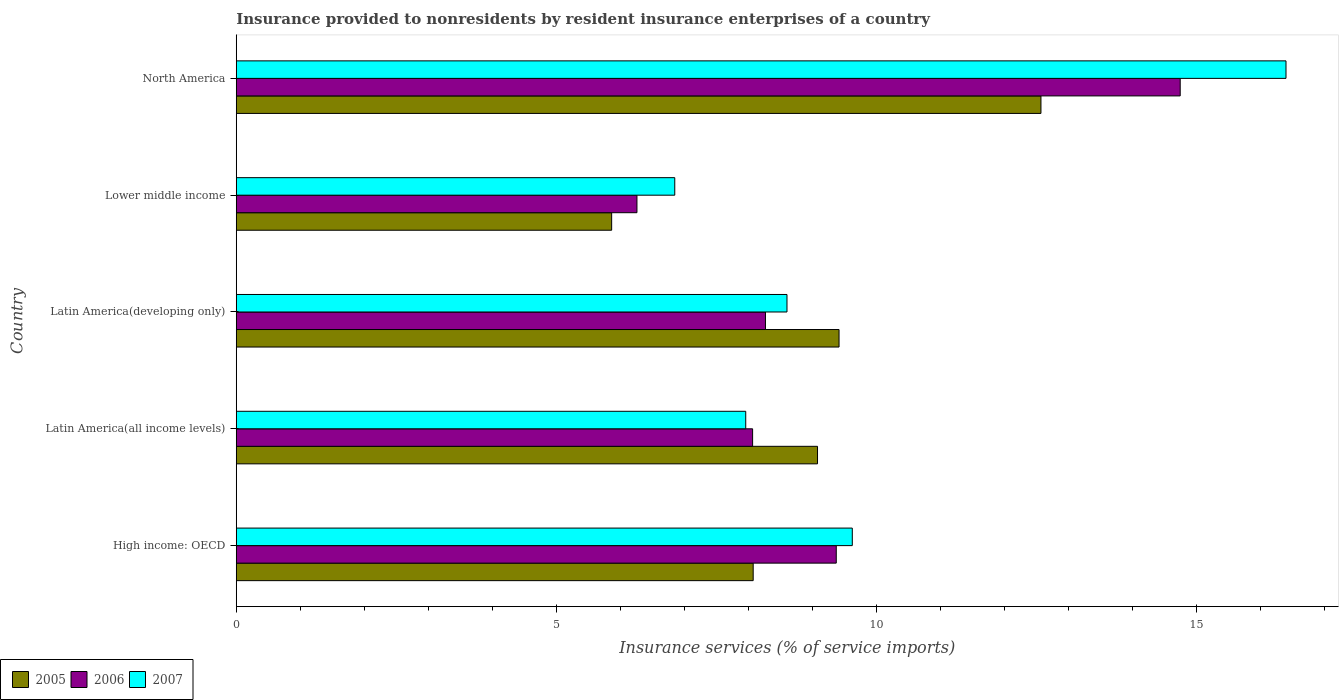How many groups of bars are there?
Ensure brevity in your answer.  5. Are the number of bars on each tick of the Y-axis equal?
Give a very brief answer. Yes. What is the label of the 2nd group of bars from the top?
Ensure brevity in your answer.  Lower middle income. What is the insurance provided to nonresidents in 2006 in North America?
Make the answer very short. 14.74. Across all countries, what is the maximum insurance provided to nonresidents in 2005?
Give a very brief answer. 12.57. Across all countries, what is the minimum insurance provided to nonresidents in 2006?
Your answer should be compact. 6.26. In which country was the insurance provided to nonresidents in 2007 maximum?
Offer a terse response. North America. In which country was the insurance provided to nonresidents in 2006 minimum?
Provide a short and direct response. Lower middle income. What is the total insurance provided to nonresidents in 2007 in the graph?
Give a very brief answer. 49.43. What is the difference between the insurance provided to nonresidents in 2005 in Latin America(developing only) and that in North America?
Make the answer very short. -3.15. What is the difference between the insurance provided to nonresidents in 2006 in High income: OECD and the insurance provided to nonresidents in 2007 in North America?
Give a very brief answer. -7.02. What is the average insurance provided to nonresidents in 2005 per country?
Make the answer very short. 9. What is the difference between the insurance provided to nonresidents in 2007 and insurance provided to nonresidents in 2006 in Lower middle income?
Keep it short and to the point. 0.59. What is the ratio of the insurance provided to nonresidents in 2005 in Latin America(all income levels) to that in North America?
Keep it short and to the point. 0.72. Is the difference between the insurance provided to nonresidents in 2007 in High income: OECD and Lower middle income greater than the difference between the insurance provided to nonresidents in 2006 in High income: OECD and Lower middle income?
Provide a succinct answer. No. What is the difference between the highest and the second highest insurance provided to nonresidents in 2006?
Offer a very short reply. 5.37. What is the difference between the highest and the lowest insurance provided to nonresidents in 2006?
Keep it short and to the point. 8.48. In how many countries, is the insurance provided to nonresidents in 2007 greater than the average insurance provided to nonresidents in 2007 taken over all countries?
Ensure brevity in your answer.  1. Is it the case that in every country, the sum of the insurance provided to nonresidents in 2006 and insurance provided to nonresidents in 2007 is greater than the insurance provided to nonresidents in 2005?
Provide a succinct answer. Yes. Are all the bars in the graph horizontal?
Provide a short and direct response. Yes. What is the difference between two consecutive major ticks on the X-axis?
Make the answer very short. 5. Are the values on the major ticks of X-axis written in scientific E-notation?
Provide a succinct answer. No. Does the graph contain any zero values?
Ensure brevity in your answer.  No. Does the graph contain grids?
Offer a very short reply. No. How many legend labels are there?
Offer a terse response. 3. How are the legend labels stacked?
Your response must be concise. Horizontal. What is the title of the graph?
Provide a succinct answer. Insurance provided to nonresidents by resident insurance enterprises of a country. Does "1999" appear as one of the legend labels in the graph?
Your response must be concise. No. What is the label or title of the X-axis?
Offer a terse response. Insurance services (% of service imports). What is the label or title of the Y-axis?
Ensure brevity in your answer.  Country. What is the Insurance services (% of service imports) of 2005 in High income: OECD?
Offer a terse response. 8.07. What is the Insurance services (% of service imports) in 2006 in High income: OECD?
Your answer should be very brief. 9.37. What is the Insurance services (% of service imports) of 2007 in High income: OECD?
Give a very brief answer. 9.62. What is the Insurance services (% of service imports) of 2005 in Latin America(all income levels)?
Keep it short and to the point. 9.08. What is the Insurance services (% of service imports) of 2006 in Latin America(all income levels)?
Keep it short and to the point. 8.06. What is the Insurance services (% of service imports) in 2007 in Latin America(all income levels)?
Offer a very short reply. 7.96. What is the Insurance services (% of service imports) in 2005 in Latin America(developing only)?
Offer a terse response. 9.41. What is the Insurance services (% of service imports) of 2006 in Latin America(developing only)?
Your answer should be compact. 8.27. What is the Insurance services (% of service imports) of 2007 in Latin America(developing only)?
Provide a succinct answer. 8.6. What is the Insurance services (% of service imports) in 2005 in Lower middle income?
Provide a succinct answer. 5.86. What is the Insurance services (% of service imports) in 2006 in Lower middle income?
Give a very brief answer. 6.26. What is the Insurance services (% of service imports) of 2007 in Lower middle income?
Make the answer very short. 6.85. What is the Insurance services (% of service imports) of 2005 in North America?
Your answer should be very brief. 12.57. What is the Insurance services (% of service imports) of 2006 in North America?
Ensure brevity in your answer.  14.74. What is the Insurance services (% of service imports) in 2007 in North America?
Your answer should be compact. 16.4. Across all countries, what is the maximum Insurance services (% of service imports) in 2005?
Keep it short and to the point. 12.57. Across all countries, what is the maximum Insurance services (% of service imports) in 2006?
Make the answer very short. 14.74. Across all countries, what is the maximum Insurance services (% of service imports) in 2007?
Provide a short and direct response. 16.4. Across all countries, what is the minimum Insurance services (% of service imports) in 2005?
Keep it short and to the point. 5.86. Across all countries, what is the minimum Insurance services (% of service imports) in 2006?
Offer a terse response. 6.26. Across all countries, what is the minimum Insurance services (% of service imports) in 2007?
Keep it short and to the point. 6.85. What is the total Insurance services (% of service imports) in 2005 in the graph?
Offer a terse response. 45. What is the total Insurance services (% of service imports) of 2006 in the graph?
Offer a terse response. 46.7. What is the total Insurance services (% of service imports) in 2007 in the graph?
Your answer should be very brief. 49.43. What is the difference between the Insurance services (% of service imports) of 2005 in High income: OECD and that in Latin America(all income levels)?
Ensure brevity in your answer.  -1. What is the difference between the Insurance services (% of service imports) of 2006 in High income: OECD and that in Latin America(all income levels)?
Your answer should be compact. 1.31. What is the difference between the Insurance services (% of service imports) in 2007 in High income: OECD and that in Latin America(all income levels)?
Offer a terse response. 1.66. What is the difference between the Insurance services (% of service imports) of 2005 in High income: OECD and that in Latin America(developing only)?
Offer a terse response. -1.34. What is the difference between the Insurance services (% of service imports) in 2006 in High income: OECD and that in Latin America(developing only)?
Offer a terse response. 1.11. What is the difference between the Insurance services (% of service imports) in 2007 in High income: OECD and that in Latin America(developing only)?
Your answer should be compact. 1.02. What is the difference between the Insurance services (% of service imports) in 2005 in High income: OECD and that in Lower middle income?
Ensure brevity in your answer.  2.21. What is the difference between the Insurance services (% of service imports) of 2006 in High income: OECD and that in Lower middle income?
Offer a terse response. 3.11. What is the difference between the Insurance services (% of service imports) in 2007 in High income: OECD and that in Lower middle income?
Offer a terse response. 2.77. What is the difference between the Insurance services (% of service imports) of 2005 in High income: OECD and that in North America?
Your answer should be compact. -4.49. What is the difference between the Insurance services (% of service imports) of 2006 in High income: OECD and that in North America?
Your answer should be very brief. -5.37. What is the difference between the Insurance services (% of service imports) in 2007 in High income: OECD and that in North America?
Give a very brief answer. -6.77. What is the difference between the Insurance services (% of service imports) in 2005 in Latin America(all income levels) and that in Latin America(developing only)?
Your response must be concise. -0.34. What is the difference between the Insurance services (% of service imports) of 2006 in Latin America(all income levels) and that in Latin America(developing only)?
Give a very brief answer. -0.2. What is the difference between the Insurance services (% of service imports) of 2007 in Latin America(all income levels) and that in Latin America(developing only)?
Make the answer very short. -0.64. What is the difference between the Insurance services (% of service imports) in 2005 in Latin America(all income levels) and that in Lower middle income?
Ensure brevity in your answer.  3.22. What is the difference between the Insurance services (% of service imports) of 2006 in Latin America(all income levels) and that in Lower middle income?
Your response must be concise. 1.81. What is the difference between the Insurance services (% of service imports) in 2007 in Latin America(all income levels) and that in Lower middle income?
Make the answer very short. 1.11. What is the difference between the Insurance services (% of service imports) of 2005 in Latin America(all income levels) and that in North America?
Ensure brevity in your answer.  -3.49. What is the difference between the Insurance services (% of service imports) in 2006 in Latin America(all income levels) and that in North America?
Provide a short and direct response. -6.68. What is the difference between the Insurance services (% of service imports) of 2007 in Latin America(all income levels) and that in North America?
Provide a short and direct response. -8.44. What is the difference between the Insurance services (% of service imports) in 2005 in Latin America(developing only) and that in Lower middle income?
Your response must be concise. 3.55. What is the difference between the Insurance services (% of service imports) in 2006 in Latin America(developing only) and that in Lower middle income?
Your answer should be very brief. 2.01. What is the difference between the Insurance services (% of service imports) in 2007 in Latin America(developing only) and that in Lower middle income?
Provide a succinct answer. 1.75. What is the difference between the Insurance services (% of service imports) in 2005 in Latin America(developing only) and that in North America?
Offer a very short reply. -3.15. What is the difference between the Insurance services (% of service imports) of 2006 in Latin America(developing only) and that in North America?
Keep it short and to the point. -6.48. What is the difference between the Insurance services (% of service imports) in 2007 in Latin America(developing only) and that in North America?
Provide a short and direct response. -7.79. What is the difference between the Insurance services (% of service imports) in 2005 in Lower middle income and that in North America?
Make the answer very short. -6.71. What is the difference between the Insurance services (% of service imports) of 2006 in Lower middle income and that in North America?
Your answer should be very brief. -8.48. What is the difference between the Insurance services (% of service imports) in 2007 in Lower middle income and that in North America?
Your answer should be very brief. -9.55. What is the difference between the Insurance services (% of service imports) of 2005 in High income: OECD and the Insurance services (% of service imports) of 2006 in Latin America(all income levels)?
Your answer should be very brief. 0.01. What is the difference between the Insurance services (% of service imports) of 2005 in High income: OECD and the Insurance services (% of service imports) of 2007 in Latin America(all income levels)?
Keep it short and to the point. 0.12. What is the difference between the Insurance services (% of service imports) in 2006 in High income: OECD and the Insurance services (% of service imports) in 2007 in Latin America(all income levels)?
Keep it short and to the point. 1.41. What is the difference between the Insurance services (% of service imports) in 2005 in High income: OECD and the Insurance services (% of service imports) in 2006 in Latin America(developing only)?
Keep it short and to the point. -0.19. What is the difference between the Insurance services (% of service imports) in 2005 in High income: OECD and the Insurance services (% of service imports) in 2007 in Latin America(developing only)?
Keep it short and to the point. -0.53. What is the difference between the Insurance services (% of service imports) of 2006 in High income: OECD and the Insurance services (% of service imports) of 2007 in Latin America(developing only)?
Provide a succinct answer. 0.77. What is the difference between the Insurance services (% of service imports) in 2005 in High income: OECD and the Insurance services (% of service imports) in 2006 in Lower middle income?
Your answer should be very brief. 1.82. What is the difference between the Insurance services (% of service imports) of 2005 in High income: OECD and the Insurance services (% of service imports) of 2007 in Lower middle income?
Provide a succinct answer. 1.22. What is the difference between the Insurance services (% of service imports) of 2006 in High income: OECD and the Insurance services (% of service imports) of 2007 in Lower middle income?
Provide a succinct answer. 2.52. What is the difference between the Insurance services (% of service imports) in 2005 in High income: OECD and the Insurance services (% of service imports) in 2006 in North America?
Your answer should be compact. -6.67. What is the difference between the Insurance services (% of service imports) of 2005 in High income: OECD and the Insurance services (% of service imports) of 2007 in North America?
Give a very brief answer. -8.32. What is the difference between the Insurance services (% of service imports) in 2006 in High income: OECD and the Insurance services (% of service imports) in 2007 in North America?
Your answer should be compact. -7.02. What is the difference between the Insurance services (% of service imports) of 2005 in Latin America(all income levels) and the Insurance services (% of service imports) of 2006 in Latin America(developing only)?
Give a very brief answer. 0.81. What is the difference between the Insurance services (% of service imports) of 2005 in Latin America(all income levels) and the Insurance services (% of service imports) of 2007 in Latin America(developing only)?
Make the answer very short. 0.48. What is the difference between the Insurance services (% of service imports) of 2006 in Latin America(all income levels) and the Insurance services (% of service imports) of 2007 in Latin America(developing only)?
Make the answer very short. -0.54. What is the difference between the Insurance services (% of service imports) of 2005 in Latin America(all income levels) and the Insurance services (% of service imports) of 2006 in Lower middle income?
Provide a short and direct response. 2.82. What is the difference between the Insurance services (% of service imports) of 2005 in Latin America(all income levels) and the Insurance services (% of service imports) of 2007 in Lower middle income?
Your response must be concise. 2.23. What is the difference between the Insurance services (% of service imports) of 2006 in Latin America(all income levels) and the Insurance services (% of service imports) of 2007 in Lower middle income?
Your response must be concise. 1.22. What is the difference between the Insurance services (% of service imports) of 2005 in Latin America(all income levels) and the Insurance services (% of service imports) of 2006 in North America?
Keep it short and to the point. -5.66. What is the difference between the Insurance services (% of service imports) in 2005 in Latin America(all income levels) and the Insurance services (% of service imports) in 2007 in North America?
Your answer should be very brief. -7.32. What is the difference between the Insurance services (% of service imports) of 2006 in Latin America(all income levels) and the Insurance services (% of service imports) of 2007 in North America?
Give a very brief answer. -8.33. What is the difference between the Insurance services (% of service imports) in 2005 in Latin America(developing only) and the Insurance services (% of service imports) in 2006 in Lower middle income?
Provide a short and direct response. 3.16. What is the difference between the Insurance services (% of service imports) of 2005 in Latin America(developing only) and the Insurance services (% of service imports) of 2007 in Lower middle income?
Give a very brief answer. 2.57. What is the difference between the Insurance services (% of service imports) in 2006 in Latin America(developing only) and the Insurance services (% of service imports) in 2007 in Lower middle income?
Provide a short and direct response. 1.42. What is the difference between the Insurance services (% of service imports) in 2005 in Latin America(developing only) and the Insurance services (% of service imports) in 2006 in North America?
Offer a terse response. -5.33. What is the difference between the Insurance services (% of service imports) of 2005 in Latin America(developing only) and the Insurance services (% of service imports) of 2007 in North America?
Provide a succinct answer. -6.98. What is the difference between the Insurance services (% of service imports) in 2006 in Latin America(developing only) and the Insurance services (% of service imports) in 2007 in North America?
Your answer should be compact. -8.13. What is the difference between the Insurance services (% of service imports) in 2005 in Lower middle income and the Insurance services (% of service imports) in 2006 in North America?
Provide a succinct answer. -8.88. What is the difference between the Insurance services (% of service imports) in 2005 in Lower middle income and the Insurance services (% of service imports) in 2007 in North America?
Your response must be concise. -10.53. What is the difference between the Insurance services (% of service imports) of 2006 in Lower middle income and the Insurance services (% of service imports) of 2007 in North America?
Provide a short and direct response. -10.14. What is the average Insurance services (% of service imports) of 2005 per country?
Ensure brevity in your answer.  9. What is the average Insurance services (% of service imports) of 2006 per country?
Your response must be concise. 9.34. What is the average Insurance services (% of service imports) in 2007 per country?
Provide a succinct answer. 9.89. What is the difference between the Insurance services (% of service imports) in 2005 and Insurance services (% of service imports) in 2006 in High income: OECD?
Ensure brevity in your answer.  -1.3. What is the difference between the Insurance services (% of service imports) of 2005 and Insurance services (% of service imports) of 2007 in High income: OECD?
Provide a succinct answer. -1.55. What is the difference between the Insurance services (% of service imports) of 2006 and Insurance services (% of service imports) of 2007 in High income: OECD?
Ensure brevity in your answer.  -0.25. What is the difference between the Insurance services (% of service imports) in 2005 and Insurance services (% of service imports) in 2006 in Latin America(all income levels)?
Make the answer very short. 1.01. What is the difference between the Insurance services (% of service imports) in 2005 and Insurance services (% of service imports) in 2007 in Latin America(all income levels)?
Ensure brevity in your answer.  1.12. What is the difference between the Insurance services (% of service imports) of 2006 and Insurance services (% of service imports) of 2007 in Latin America(all income levels)?
Your answer should be very brief. 0.11. What is the difference between the Insurance services (% of service imports) in 2005 and Insurance services (% of service imports) in 2006 in Latin America(developing only)?
Offer a terse response. 1.15. What is the difference between the Insurance services (% of service imports) in 2005 and Insurance services (% of service imports) in 2007 in Latin America(developing only)?
Provide a succinct answer. 0.81. What is the difference between the Insurance services (% of service imports) in 2006 and Insurance services (% of service imports) in 2007 in Latin America(developing only)?
Your answer should be very brief. -0.34. What is the difference between the Insurance services (% of service imports) in 2005 and Insurance services (% of service imports) in 2006 in Lower middle income?
Provide a succinct answer. -0.4. What is the difference between the Insurance services (% of service imports) of 2005 and Insurance services (% of service imports) of 2007 in Lower middle income?
Your answer should be very brief. -0.99. What is the difference between the Insurance services (% of service imports) in 2006 and Insurance services (% of service imports) in 2007 in Lower middle income?
Make the answer very short. -0.59. What is the difference between the Insurance services (% of service imports) in 2005 and Insurance services (% of service imports) in 2006 in North America?
Ensure brevity in your answer.  -2.17. What is the difference between the Insurance services (% of service imports) in 2005 and Insurance services (% of service imports) in 2007 in North America?
Provide a short and direct response. -3.83. What is the difference between the Insurance services (% of service imports) in 2006 and Insurance services (% of service imports) in 2007 in North America?
Give a very brief answer. -1.65. What is the ratio of the Insurance services (% of service imports) in 2005 in High income: OECD to that in Latin America(all income levels)?
Make the answer very short. 0.89. What is the ratio of the Insurance services (% of service imports) in 2006 in High income: OECD to that in Latin America(all income levels)?
Your answer should be compact. 1.16. What is the ratio of the Insurance services (% of service imports) of 2007 in High income: OECD to that in Latin America(all income levels)?
Give a very brief answer. 1.21. What is the ratio of the Insurance services (% of service imports) of 2005 in High income: OECD to that in Latin America(developing only)?
Your answer should be compact. 0.86. What is the ratio of the Insurance services (% of service imports) of 2006 in High income: OECD to that in Latin America(developing only)?
Offer a very short reply. 1.13. What is the ratio of the Insurance services (% of service imports) in 2007 in High income: OECD to that in Latin America(developing only)?
Your response must be concise. 1.12. What is the ratio of the Insurance services (% of service imports) in 2005 in High income: OECD to that in Lower middle income?
Offer a terse response. 1.38. What is the ratio of the Insurance services (% of service imports) of 2006 in High income: OECD to that in Lower middle income?
Keep it short and to the point. 1.5. What is the ratio of the Insurance services (% of service imports) of 2007 in High income: OECD to that in Lower middle income?
Offer a very short reply. 1.4. What is the ratio of the Insurance services (% of service imports) in 2005 in High income: OECD to that in North America?
Provide a succinct answer. 0.64. What is the ratio of the Insurance services (% of service imports) in 2006 in High income: OECD to that in North America?
Your answer should be very brief. 0.64. What is the ratio of the Insurance services (% of service imports) of 2007 in High income: OECD to that in North America?
Provide a succinct answer. 0.59. What is the ratio of the Insurance services (% of service imports) of 2005 in Latin America(all income levels) to that in Latin America(developing only)?
Give a very brief answer. 0.96. What is the ratio of the Insurance services (% of service imports) in 2006 in Latin America(all income levels) to that in Latin America(developing only)?
Ensure brevity in your answer.  0.98. What is the ratio of the Insurance services (% of service imports) in 2007 in Latin America(all income levels) to that in Latin America(developing only)?
Offer a very short reply. 0.93. What is the ratio of the Insurance services (% of service imports) of 2005 in Latin America(all income levels) to that in Lower middle income?
Make the answer very short. 1.55. What is the ratio of the Insurance services (% of service imports) of 2006 in Latin America(all income levels) to that in Lower middle income?
Provide a succinct answer. 1.29. What is the ratio of the Insurance services (% of service imports) of 2007 in Latin America(all income levels) to that in Lower middle income?
Offer a terse response. 1.16. What is the ratio of the Insurance services (% of service imports) of 2005 in Latin America(all income levels) to that in North America?
Your answer should be very brief. 0.72. What is the ratio of the Insurance services (% of service imports) of 2006 in Latin America(all income levels) to that in North America?
Keep it short and to the point. 0.55. What is the ratio of the Insurance services (% of service imports) in 2007 in Latin America(all income levels) to that in North America?
Ensure brevity in your answer.  0.49. What is the ratio of the Insurance services (% of service imports) in 2005 in Latin America(developing only) to that in Lower middle income?
Your response must be concise. 1.61. What is the ratio of the Insurance services (% of service imports) of 2006 in Latin America(developing only) to that in Lower middle income?
Ensure brevity in your answer.  1.32. What is the ratio of the Insurance services (% of service imports) of 2007 in Latin America(developing only) to that in Lower middle income?
Your response must be concise. 1.26. What is the ratio of the Insurance services (% of service imports) in 2005 in Latin America(developing only) to that in North America?
Your response must be concise. 0.75. What is the ratio of the Insurance services (% of service imports) in 2006 in Latin America(developing only) to that in North America?
Your answer should be compact. 0.56. What is the ratio of the Insurance services (% of service imports) of 2007 in Latin America(developing only) to that in North America?
Offer a terse response. 0.52. What is the ratio of the Insurance services (% of service imports) of 2005 in Lower middle income to that in North America?
Your response must be concise. 0.47. What is the ratio of the Insurance services (% of service imports) of 2006 in Lower middle income to that in North America?
Offer a very short reply. 0.42. What is the ratio of the Insurance services (% of service imports) in 2007 in Lower middle income to that in North America?
Your response must be concise. 0.42. What is the difference between the highest and the second highest Insurance services (% of service imports) of 2005?
Your answer should be very brief. 3.15. What is the difference between the highest and the second highest Insurance services (% of service imports) in 2006?
Your response must be concise. 5.37. What is the difference between the highest and the second highest Insurance services (% of service imports) in 2007?
Give a very brief answer. 6.77. What is the difference between the highest and the lowest Insurance services (% of service imports) of 2005?
Give a very brief answer. 6.71. What is the difference between the highest and the lowest Insurance services (% of service imports) in 2006?
Provide a short and direct response. 8.48. What is the difference between the highest and the lowest Insurance services (% of service imports) in 2007?
Keep it short and to the point. 9.55. 